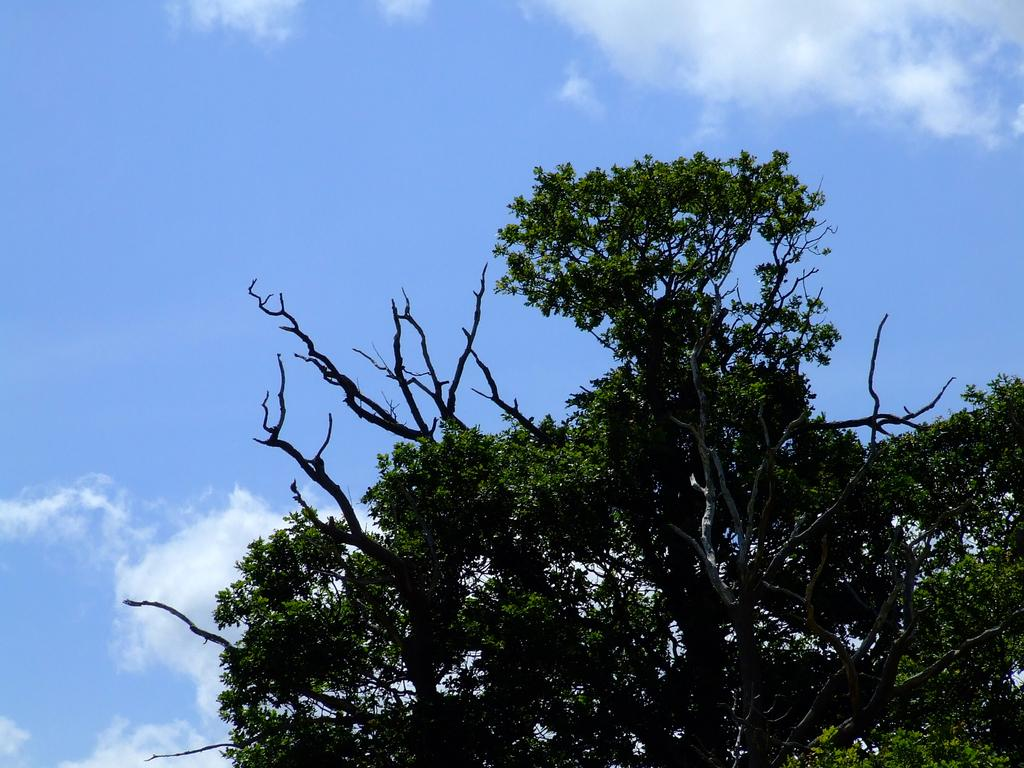What type of vegetation can be seen in the image? There are trees with branches and leaves in the image. What is visible at the top of the image? The sky is visible at the top of the image. What can be seen in the sky in the image? Clouds are present in the sky. How does the tramp contribute to the image? There is no tramp present in the image. What is the partner's role in the image? There is no partner mentioned or depicted in the image. 